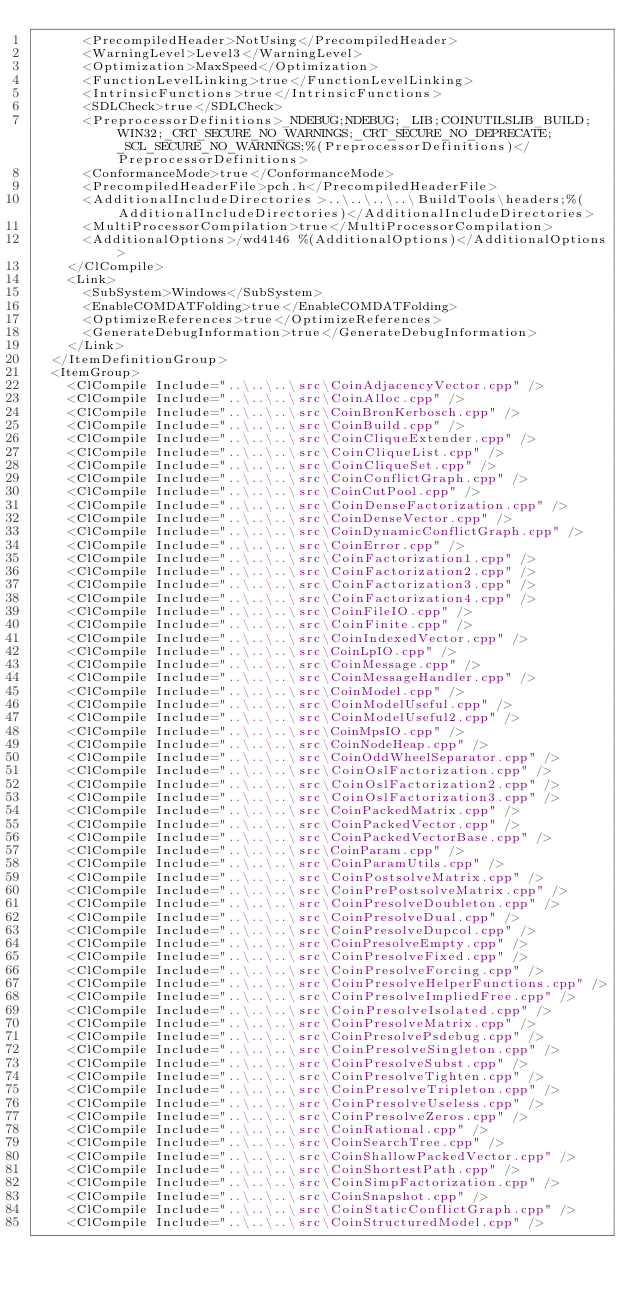Convert code to text. <code><loc_0><loc_0><loc_500><loc_500><_XML_>      <PrecompiledHeader>NotUsing</PrecompiledHeader>
      <WarningLevel>Level3</WarningLevel>
      <Optimization>MaxSpeed</Optimization>
      <FunctionLevelLinking>true</FunctionLevelLinking>
      <IntrinsicFunctions>true</IntrinsicFunctions>
      <SDLCheck>true</SDLCheck>
      <PreprocessorDefinitions>_NDEBUG;NDEBUG;_LIB;COINUTILSLIB_BUILD;WIN32;_CRT_SECURE_NO_WARNINGS;_CRT_SECURE_NO_DEPRECATE;_SCL_SECURE_NO_WARNINGS;%(PreprocessorDefinitions)</PreprocessorDefinitions>
      <ConformanceMode>true</ConformanceMode>
      <PrecompiledHeaderFile>pch.h</PrecompiledHeaderFile>
      <AdditionalIncludeDirectories>..\..\..\..\BuildTools\headers;%(AdditionalIncludeDirectories)</AdditionalIncludeDirectories>
      <MultiProcessorCompilation>true</MultiProcessorCompilation>
      <AdditionalOptions>/wd4146 %(AdditionalOptions)</AdditionalOptions>
    </ClCompile>
    <Link>
      <SubSystem>Windows</SubSystem>
      <EnableCOMDATFolding>true</EnableCOMDATFolding>
      <OptimizeReferences>true</OptimizeReferences>
      <GenerateDebugInformation>true</GenerateDebugInformation>
    </Link>
  </ItemDefinitionGroup>
  <ItemGroup>
    <ClCompile Include="..\..\..\src\CoinAdjacencyVector.cpp" />
    <ClCompile Include="..\..\..\src\CoinAlloc.cpp" />
    <ClCompile Include="..\..\..\src\CoinBronKerbosch.cpp" />
    <ClCompile Include="..\..\..\src\CoinBuild.cpp" />
    <ClCompile Include="..\..\..\src\CoinCliqueExtender.cpp" />
    <ClCompile Include="..\..\..\src\CoinCliqueList.cpp" />
    <ClCompile Include="..\..\..\src\CoinCliqueSet.cpp" />
    <ClCompile Include="..\..\..\src\CoinConflictGraph.cpp" />
    <ClCompile Include="..\..\..\src\CoinCutPool.cpp" />
    <ClCompile Include="..\..\..\src\CoinDenseFactorization.cpp" />
    <ClCompile Include="..\..\..\src\CoinDenseVector.cpp" />
    <ClCompile Include="..\..\..\src\CoinDynamicConflictGraph.cpp" />
    <ClCompile Include="..\..\..\src\CoinError.cpp" />
    <ClCompile Include="..\..\..\src\CoinFactorization1.cpp" />
    <ClCompile Include="..\..\..\src\CoinFactorization2.cpp" />
    <ClCompile Include="..\..\..\src\CoinFactorization3.cpp" />
    <ClCompile Include="..\..\..\src\CoinFactorization4.cpp" />
    <ClCompile Include="..\..\..\src\CoinFileIO.cpp" />
    <ClCompile Include="..\..\..\src\CoinFinite.cpp" />
    <ClCompile Include="..\..\..\src\CoinIndexedVector.cpp" />
    <ClCompile Include="..\..\..\src\CoinLpIO.cpp" />
    <ClCompile Include="..\..\..\src\CoinMessage.cpp" />
    <ClCompile Include="..\..\..\src\CoinMessageHandler.cpp" />
    <ClCompile Include="..\..\..\src\CoinModel.cpp" />
    <ClCompile Include="..\..\..\src\CoinModelUseful.cpp" />
    <ClCompile Include="..\..\..\src\CoinModelUseful2.cpp" />
    <ClCompile Include="..\..\..\src\CoinMpsIO.cpp" />
    <ClCompile Include="..\..\..\src\CoinNodeHeap.cpp" />
    <ClCompile Include="..\..\..\src\CoinOddWheelSeparator.cpp" />
    <ClCompile Include="..\..\..\src\CoinOslFactorization.cpp" />
    <ClCompile Include="..\..\..\src\CoinOslFactorization2.cpp" />
    <ClCompile Include="..\..\..\src\CoinOslFactorization3.cpp" />
    <ClCompile Include="..\..\..\src\CoinPackedMatrix.cpp" />
    <ClCompile Include="..\..\..\src\CoinPackedVector.cpp" />
    <ClCompile Include="..\..\..\src\CoinPackedVectorBase.cpp" />
    <ClCompile Include="..\..\..\src\CoinParam.cpp" />
    <ClCompile Include="..\..\..\src\CoinParamUtils.cpp" />
    <ClCompile Include="..\..\..\src\CoinPostsolveMatrix.cpp" />
    <ClCompile Include="..\..\..\src\CoinPrePostsolveMatrix.cpp" />
    <ClCompile Include="..\..\..\src\CoinPresolveDoubleton.cpp" />
    <ClCompile Include="..\..\..\src\CoinPresolveDual.cpp" />
    <ClCompile Include="..\..\..\src\CoinPresolveDupcol.cpp" />
    <ClCompile Include="..\..\..\src\CoinPresolveEmpty.cpp" />
    <ClCompile Include="..\..\..\src\CoinPresolveFixed.cpp" />
    <ClCompile Include="..\..\..\src\CoinPresolveForcing.cpp" />
    <ClCompile Include="..\..\..\src\CoinPresolveHelperFunctions.cpp" />
    <ClCompile Include="..\..\..\src\CoinPresolveImpliedFree.cpp" />
    <ClCompile Include="..\..\..\src\CoinPresolveIsolated.cpp" />
    <ClCompile Include="..\..\..\src\CoinPresolveMatrix.cpp" />
    <ClCompile Include="..\..\..\src\CoinPresolvePsdebug.cpp" />
    <ClCompile Include="..\..\..\src\CoinPresolveSingleton.cpp" />
    <ClCompile Include="..\..\..\src\CoinPresolveSubst.cpp" />
    <ClCompile Include="..\..\..\src\CoinPresolveTighten.cpp" />
    <ClCompile Include="..\..\..\src\CoinPresolveTripleton.cpp" />
    <ClCompile Include="..\..\..\src\CoinPresolveUseless.cpp" />
    <ClCompile Include="..\..\..\src\CoinPresolveZeros.cpp" />
    <ClCompile Include="..\..\..\src\CoinRational.cpp" />
    <ClCompile Include="..\..\..\src\CoinSearchTree.cpp" />
    <ClCompile Include="..\..\..\src\CoinShallowPackedVector.cpp" />
    <ClCompile Include="..\..\..\src\CoinShortestPath.cpp" />
    <ClCompile Include="..\..\..\src\CoinSimpFactorization.cpp" />
    <ClCompile Include="..\..\..\src\CoinSnapshot.cpp" />
    <ClCompile Include="..\..\..\src\CoinStaticConflictGraph.cpp" />
    <ClCompile Include="..\..\..\src\CoinStructuredModel.cpp" /></code> 